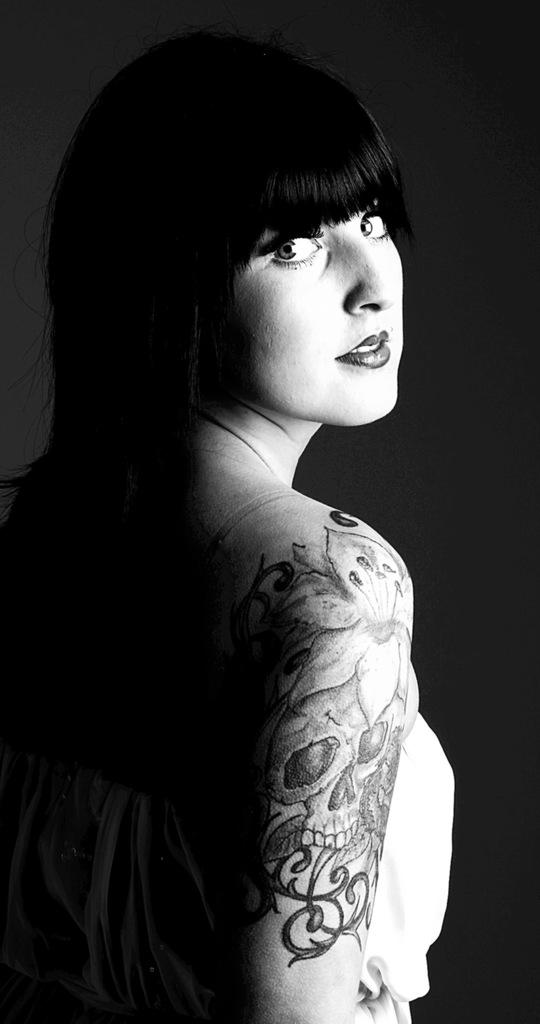Who is the main subject in the image? There is a woman in the image. What is the woman doing in the image? The woman is standing. Can you describe any unique features of the woman? The woman has tattoos on her hand. What is the color scheme of the image? The image is black and white. What type of basket is the woman holding in the image? There is no basket present in the image. What request is the woman making in the image? There is no indication of a request being made in the image. 